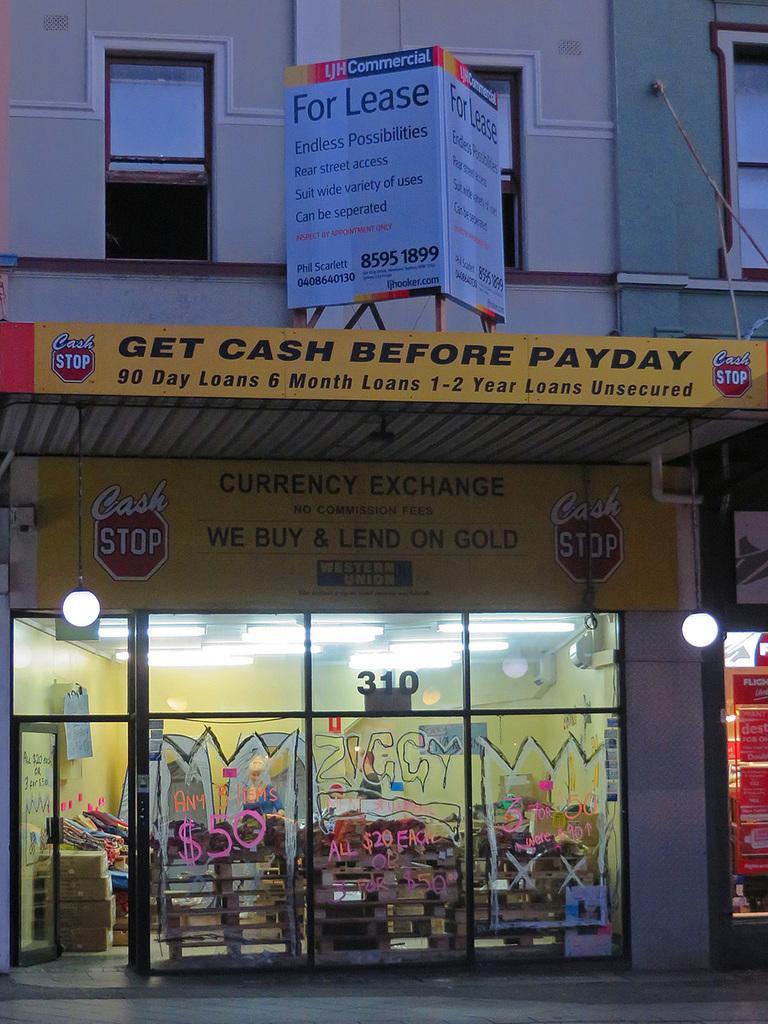Could you give a brief overview of what you see in this image? In this image, we can see glass wall, door. Through the glass wall, we can see some objects. In the middle of the image, we can see some boards, lights, hoarding. Top of the image, we can see glass windows, pipes. 